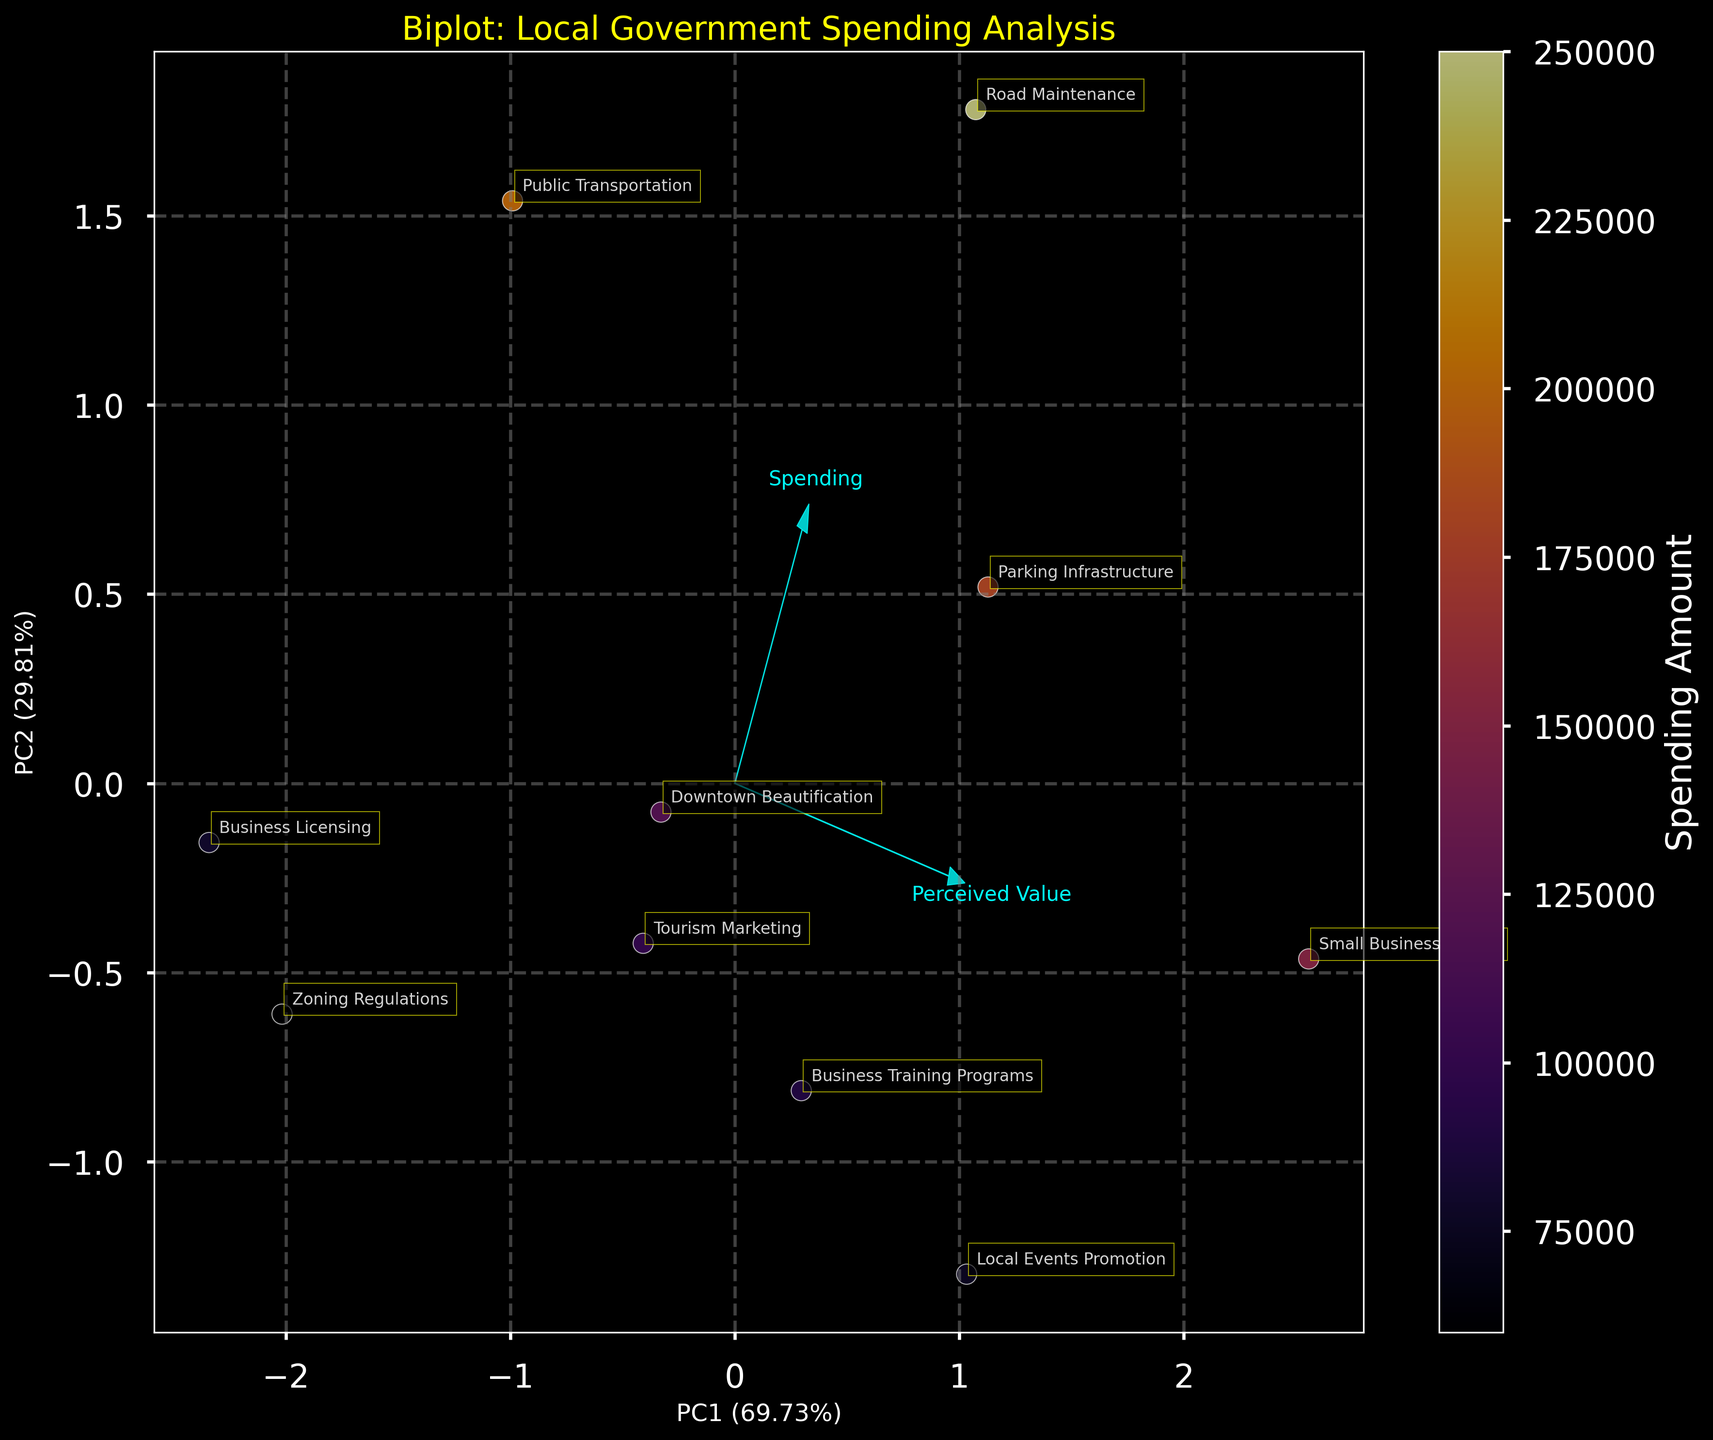What's the title of the plot? The title is located at the top center of the plot. It is usually in a larger font size and often colored differently to stand out.
Answer: Biplot: Local Government Spending Analysis How many categories of local government spending are shown? By counting the different data points or labels on the plot, we can identify the total number of unique categories.
Answer: 10 Which category is associated with the highest spending amount? Look for the data point with the highest value along the color bar indicating 'Spending Amount'. The corresponding label is the category.
Answer: Road Maintenance Which two categories have the highest perceived value and business impact? Locate the data points that are farthest along the vectors for 'Perceived Value' and 'Business Impact'. The corresponding labels are the categories.
Answer: Small Business Grants and Local Events Promotion What does PC1 represent in the biplot, and what's its explained variance? The x-axis label provides this information.
Answer: PC1 represents the first principal component with 67% variance Which category is closest to the origin of the PCA plot? Observe the data points near (0,0) to identify the closest label.
Answer: Zoning Regulations How is 'Public Transportation' perceived in terms of value and impact? Locate the 'Public Transportation' data point and check its positioning relative to the vectors for 'Perceived Value' and 'Business Impact'.
Answer: Moderate perceived value and impact What does the color bar on the right side represent? Typically, the color bar signifies a variable, and its label will indicate what it represents.
Answer: Spending Amount Which categories have below-average business impact but above-average perceived value? Look for data points below the business impact vector (0 on PC2 for impact) and above the perceived value vector. Compare their positions against the average.
Answer: Business Training Programs How do the vectors for 'Perceived Value' and 'Business Impact' compare in length and direction? Examine the feature vectors in the plot. We assess their trajectory from the origin and their length to compare.
Answer: Both are similar in length but point in slightly different directions 